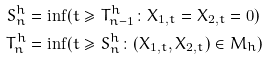Convert formula to latex. <formula><loc_0><loc_0><loc_500><loc_500>S ^ { h } _ { n } & = \inf ( t \geq T ^ { h } _ { n - 1 } \colon X _ { 1 , t } = X _ { 2 , t } = 0 ) \\ T ^ { h } _ { n } & = \inf ( t \geq S ^ { h } _ { n } \colon ( X _ { 1 , t } , X _ { 2 , t } ) \in M _ { h } )</formula> 